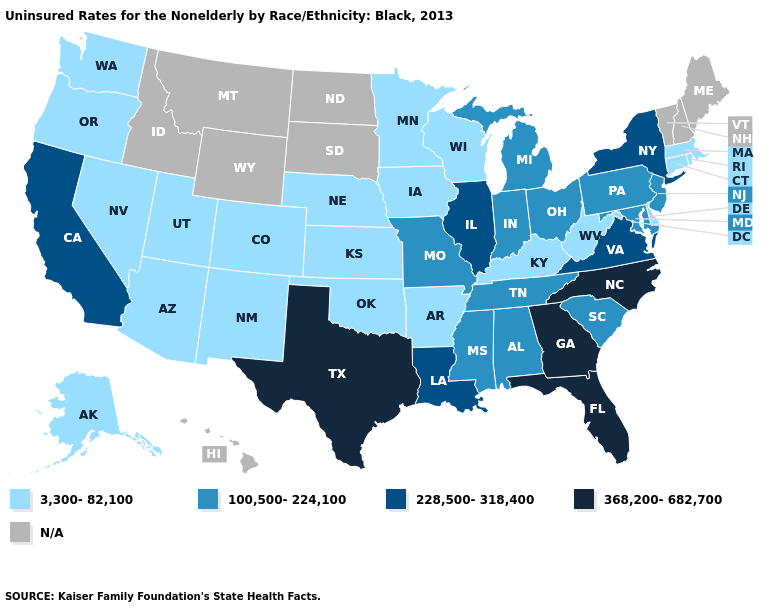Does Texas have the highest value in the USA?
Concise answer only. Yes. What is the lowest value in the USA?
Short answer required. 3,300-82,100. Among the states that border Pennsylvania , which have the lowest value?
Keep it brief. Delaware, West Virginia. Which states have the highest value in the USA?
Concise answer only. Florida, Georgia, North Carolina, Texas. What is the value of California?
Short answer required. 228,500-318,400. Which states have the highest value in the USA?
Short answer required. Florida, Georgia, North Carolina, Texas. What is the value of Colorado?
Write a very short answer. 3,300-82,100. Name the states that have a value in the range 368,200-682,700?
Answer briefly. Florida, Georgia, North Carolina, Texas. Which states have the lowest value in the USA?
Be succinct. Alaska, Arizona, Arkansas, Colorado, Connecticut, Delaware, Iowa, Kansas, Kentucky, Massachusetts, Minnesota, Nebraska, Nevada, New Mexico, Oklahoma, Oregon, Rhode Island, Utah, Washington, West Virginia, Wisconsin. Name the states that have a value in the range N/A?
Give a very brief answer. Hawaii, Idaho, Maine, Montana, New Hampshire, North Dakota, South Dakota, Vermont, Wyoming. Is the legend a continuous bar?
Give a very brief answer. No. Name the states that have a value in the range N/A?
Give a very brief answer. Hawaii, Idaho, Maine, Montana, New Hampshire, North Dakota, South Dakota, Vermont, Wyoming. What is the value of Florida?
Be succinct. 368,200-682,700. Name the states that have a value in the range 3,300-82,100?
Concise answer only. Alaska, Arizona, Arkansas, Colorado, Connecticut, Delaware, Iowa, Kansas, Kentucky, Massachusetts, Minnesota, Nebraska, Nevada, New Mexico, Oklahoma, Oregon, Rhode Island, Utah, Washington, West Virginia, Wisconsin. Name the states that have a value in the range 3,300-82,100?
Be succinct. Alaska, Arizona, Arkansas, Colorado, Connecticut, Delaware, Iowa, Kansas, Kentucky, Massachusetts, Minnesota, Nebraska, Nevada, New Mexico, Oklahoma, Oregon, Rhode Island, Utah, Washington, West Virginia, Wisconsin. 